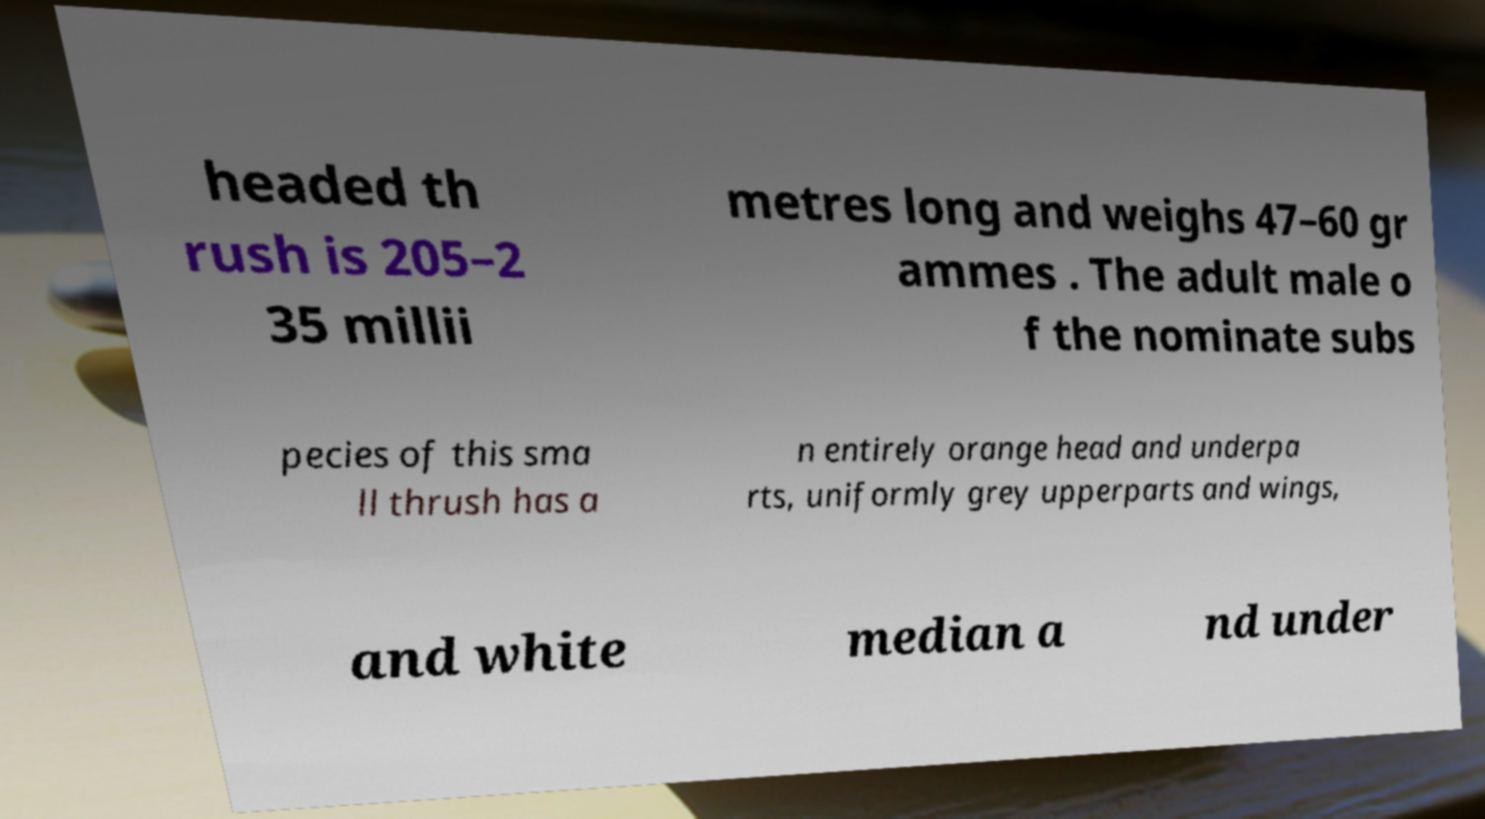For documentation purposes, I need the text within this image transcribed. Could you provide that? headed th rush is 205–2 35 millii metres long and weighs 47–60 gr ammes . The adult male o f the nominate subs pecies of this sma ll thrush has a n entirely orange head and underpa rts, uniformly grey upperparts and wings, and white median a nd under 